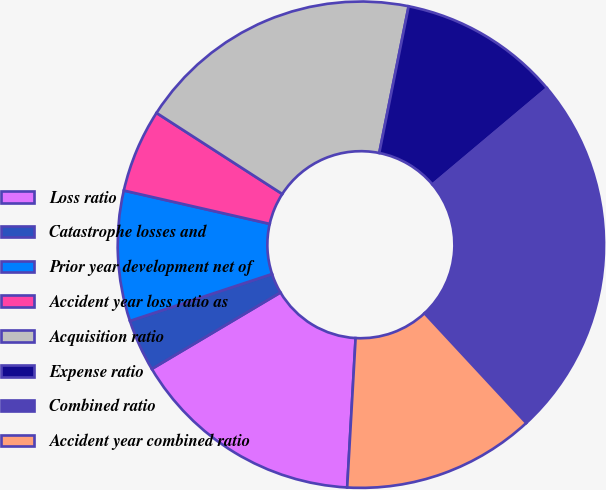<chart> <loc_0><loc_0><loc_500><loc_500><pie_chart><fcel>Loss ratio<fcel>Catastrophe losses and<fcel>Prior year development net of<fcel>Accident year loss ratio as<fcel>Acquisition ratio<fcel>Expense ratio<fcel>Combined ratio<fcel>Accident year combined ratio<nl><fcel>15.57%<fcel>3.46%<fcel>8.65%<fcel>5.54%<fcel>19.03%<fcel>10.73%<fcel>24.22%<fcel>12.8%<nl></chart> 